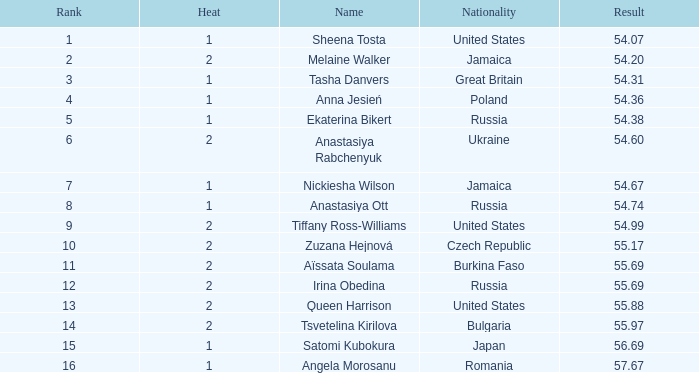Which nationality possesses a heat less than 2 and holds a rank of 15? Japan. 